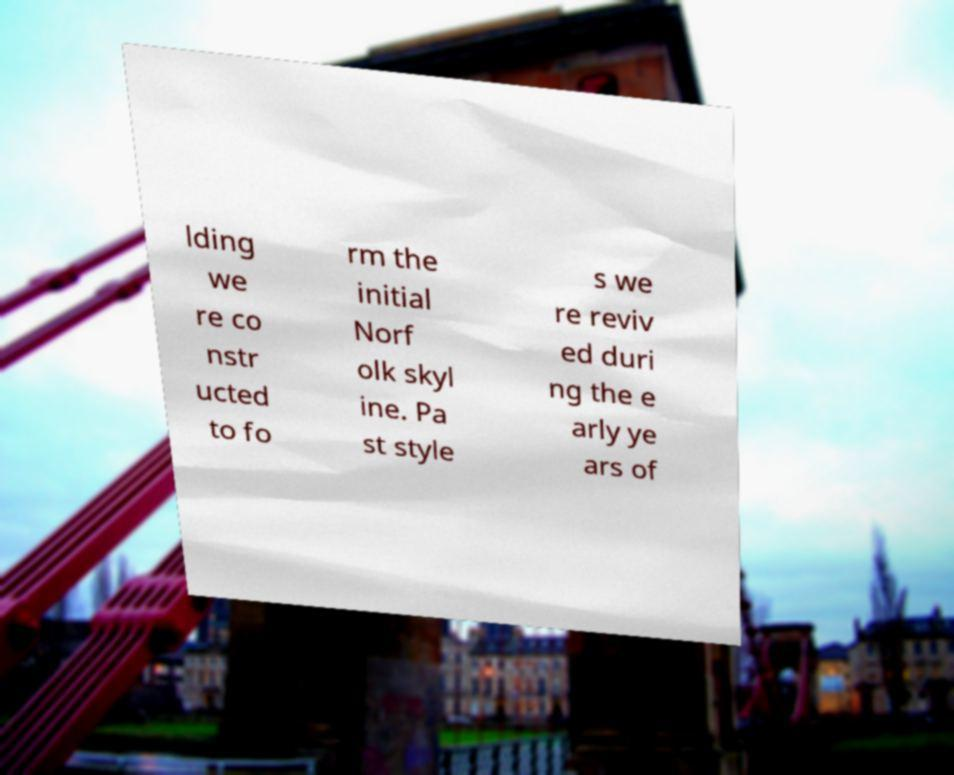Could you assist in decoding the text presented in this image and type it out clearly? lding we re co nstr ucted to fo rm the initial Norf olk skyl ine. Pa st style s we re reviv ed duri ng the e arly ye ars of 